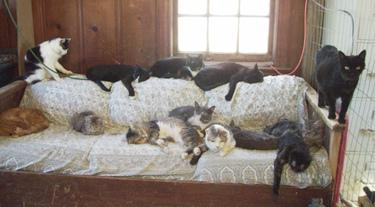What is the paneling made of which is covering the walls?

Choices:
A) cedar
B) oak
C) birch
D) pine pine 